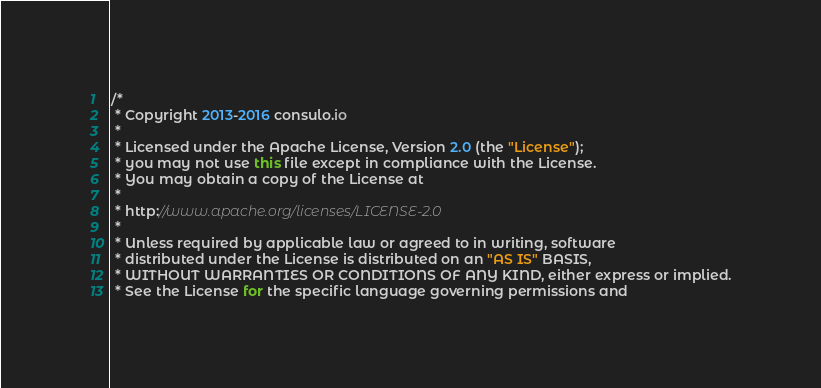<code> <loc_0><loc_0><loc_500><loc_500><_Java_>/*
 * Copyright 2013-2016 consulo.io
 *
 * Licensed under the Apache License, Version 2.0 (the "License");
 * you may not use this file except in compliance with the License.
 * You may obtain a copy of the License at
 *
 * http://www.apache.org/licenses/LICENSE-2.0
 *
 * Unless required by applicable law or agreed to in writing, software
 * distributed under the License is distributed on an "AS IS" BASIS,
 * WITHOUT WARRANTIES OR CONDITIONS OF ANY KIND, either express or implied.
 * See the License for the specific language governing permissions and</code> 